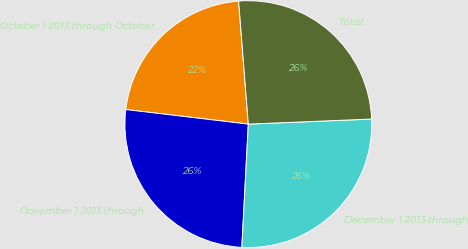Convert chart to OTSL. <chart><loc_0><loc_0><loc_500><loc_500><pie_chart><fcel>October 1 2013 through October<fcel>November 1 2013 through<fcel>December 1 2013 through<fcel>Total<nl><fcel>21.86%<fcel>26.05%<fcel>26.49%<fcel>25.6%<nl></chart> 